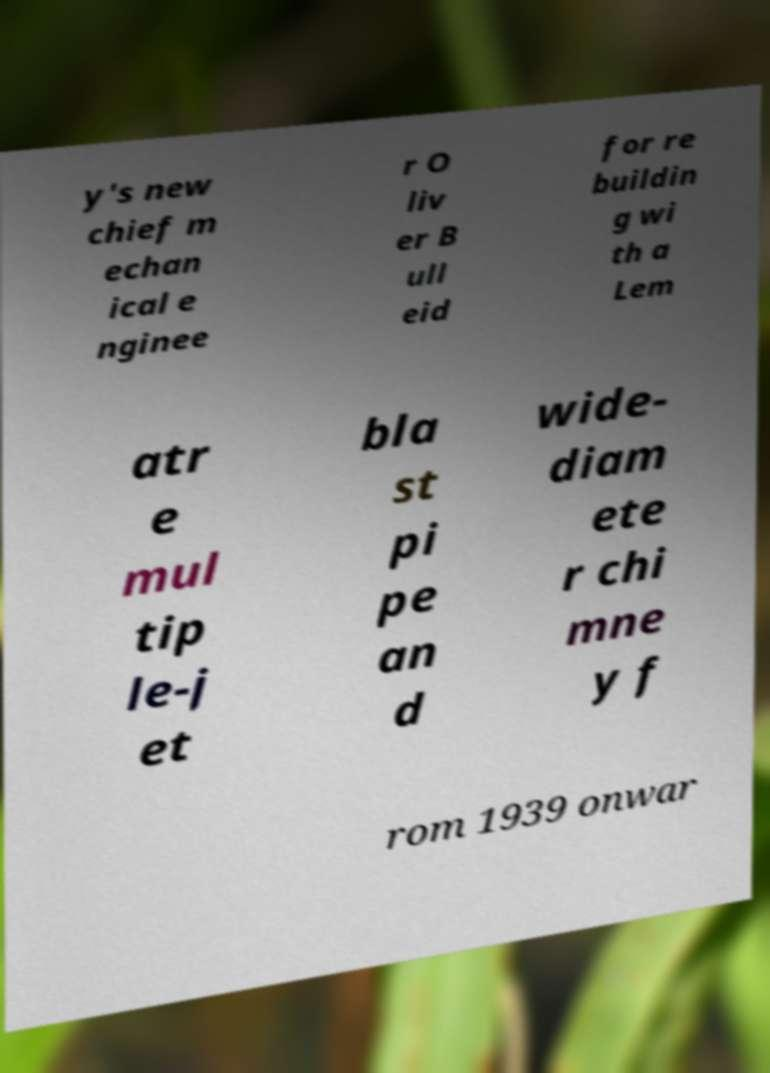I need the written content from this picture converted into text. Can you do that? y's new chief m echan ical e nginee r O liv er B ull eid for re buildin g wi th a Lem atr e mul tip le-j et bla st pi pe an d wide- diam ete r chi mne y f rom 1939 onwar 